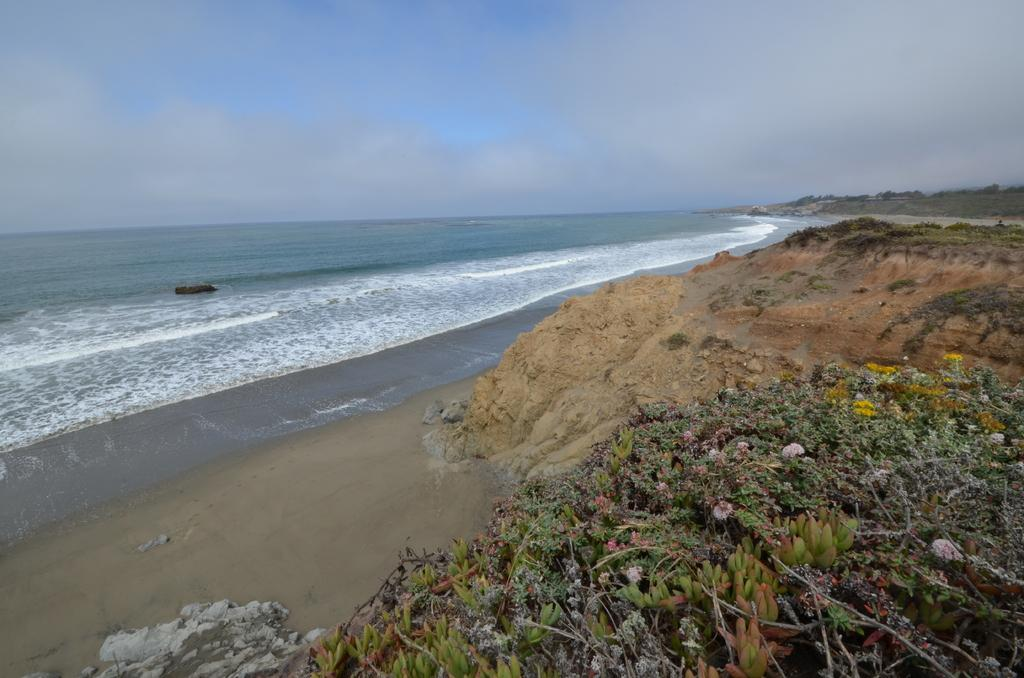What natural feature is the main subject of the image? The image contains the ocean. What type of vegetation can be seen at the bottom of the image? There are flowers on a plant at the bottom of the image. What can be seen in the right background of the image? There are trees in the right background of the image. What is visible at the top of the image? The sky is visible at the top of the image. What type of weather can be inferred from the sky? Clouds are present in the sky, suggesting a partly cloudy day. What action is the son performing in the image? There is no son present in the image; it features the ocean, flowers, trees, and a sky with clouds. 